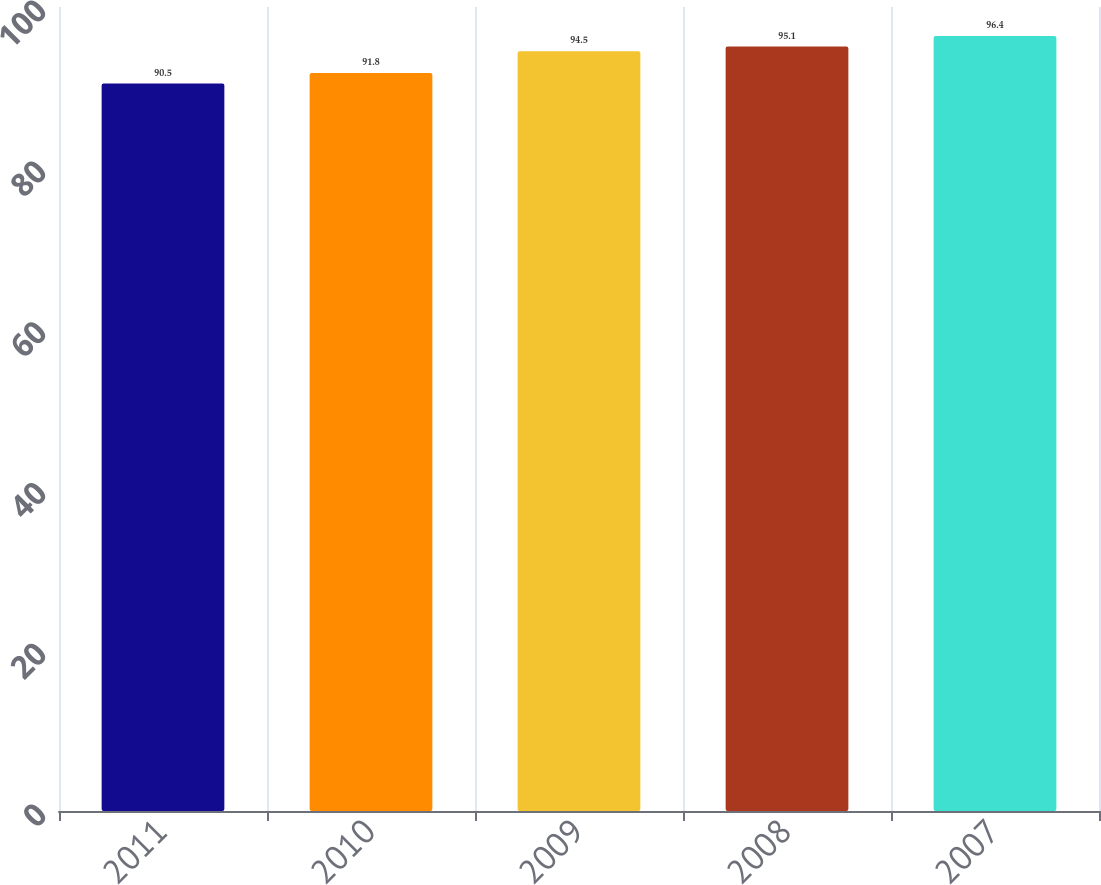<chart> <loc_0><loc_0><loc_500><loc_500><bar_chart><fcel>2011<fcel>2010<fcel>2009<fcel>2008<fcel>2007<nl><fcel>90.5<fcel>91.8<fcel>94.5<fcel>95.1<fcel>96.4<nl></chart> 